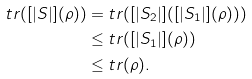<formula> <loc_0><loc_0><loc_500><loc_500>t r ( [ | S | ] ( \rho ) ) & = t r ( [ | S _ { 2 } | ] ( [ | S _ { 1 } | ] ( \rho ) ) ) \\ & \leq t r ( [ | S _ { 1 } | ] ( \rho ) ) \\ & \leq t r ( \rho ) .</formula> 